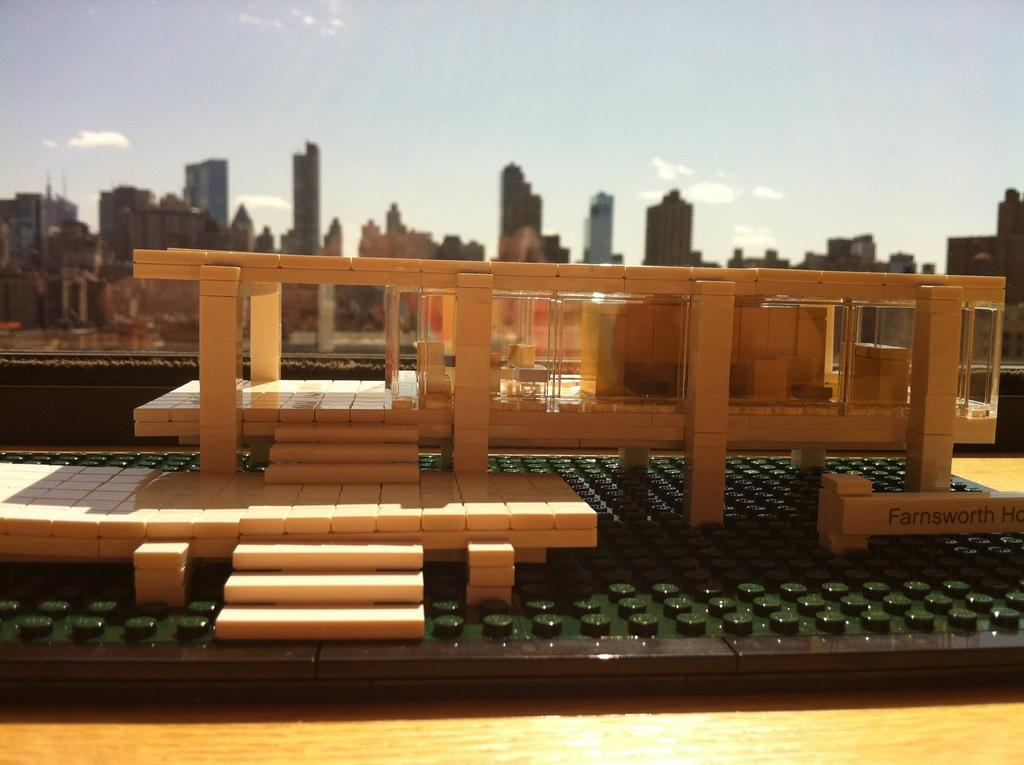What is the main subject of the image? The main subject of the image is a miniature building. Where is the miniature building located? The miniature building is on a wooden platform. What can be seen in the background of the image? There is a glass element, other buildings, and the sky visible in the background of the image. What type of insect can be seen crawling on the miniature building in the image? There are no insects visible on the miniature building in the image. What view can be seen from the miniature building in the image? The image does not provide a view from the miniature building, as it is a static image of the building itself. 